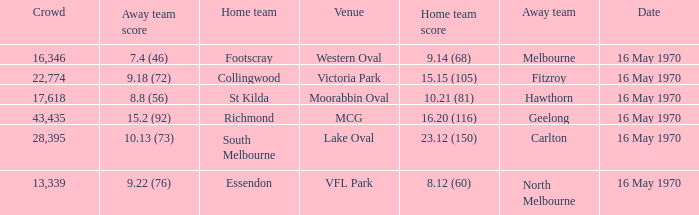Could you help me parse every detail presented in this table? {'header': ['Crowd', 'Away team score', 'Home team', 'Venue', 'Home team score', 'Away team', 'Date'], 'rows': [['16,346', '7.4 (46)', 'Footscray', 'Western Oval', '9.14 (68)', 'Melbourne', '16 May 1970'], ['22,774', '9.18 (72)', 'Collingwood', 'Victoria Park', '15.15 (105)', 'Fitzroy', '16 May 1970'], ['17,618', '8.8 (56)', 'St Kilda', 'Moorabbin Oval', '10.21 (81)', 'Hawthorn', '16 May 1970'], ['43,435', '15.2 (92)', 'Richmond', 'MCG', '16.20 (116)', 'Geelong', '16 May 1970'], ['28,395', '10.13 (73)', 'South Melbourne', 'Lake Oval', '23.12 (150)', 'Carlton', '16 May 1970'], ['13,339', '9.22 (76)', 'Essendon', 'VFL Park', '8.12 (60)', 'North Melbourne', '16 May 1970']]} What did the away team score when the home team was south melbourne? 10.13 (73). 